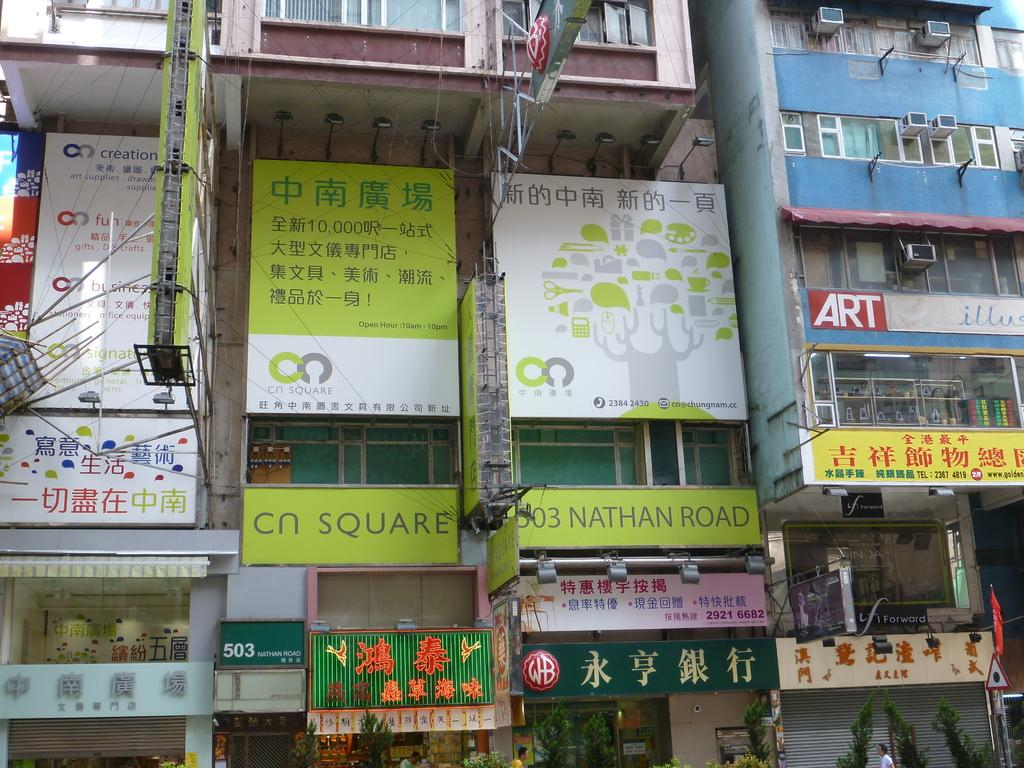<image>
Summarize the visual content of the image. City buildings are covered with advertisement signs, in the midst of which is a sign that says 303 Nathan Road. 